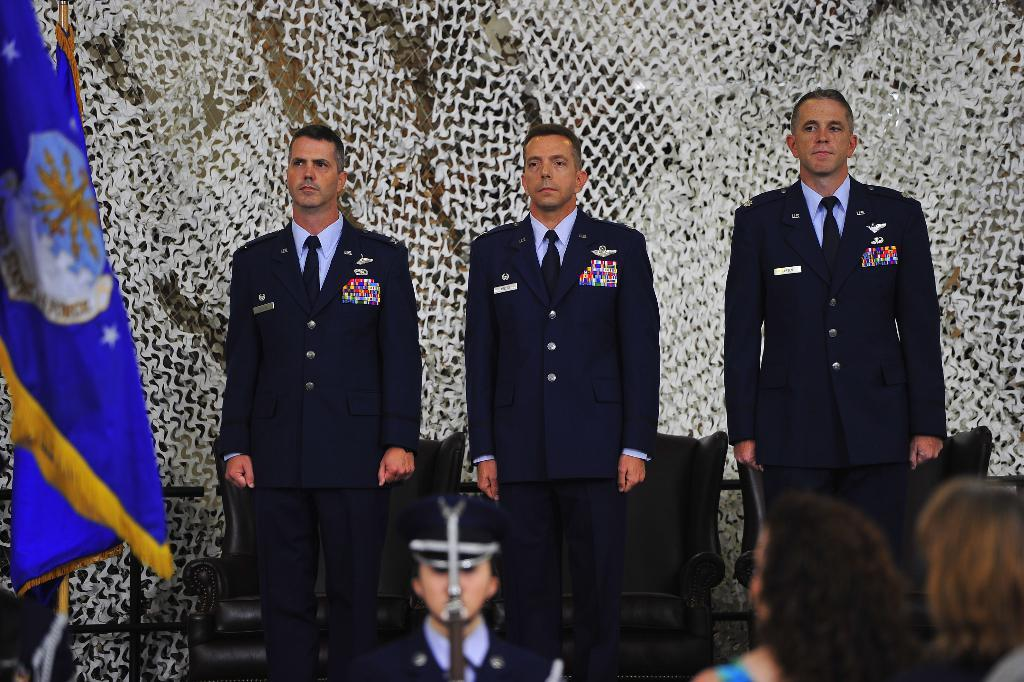How many people are present in the image? There are three persons standing in the image. What are the people wearing? The persons are wearing blue color uniforms. What can be seen in the background of the image? There is a flag in the background of the image. What is the color of the flag? The flag is blue in color. What type of event are the people attending in the image? There is no indication of an event in the image; it only shows three people wearing blue uniforms and a blue flag in the background. What educational institution do the people represent in the image? There is no indication of an educational institution in the image. 